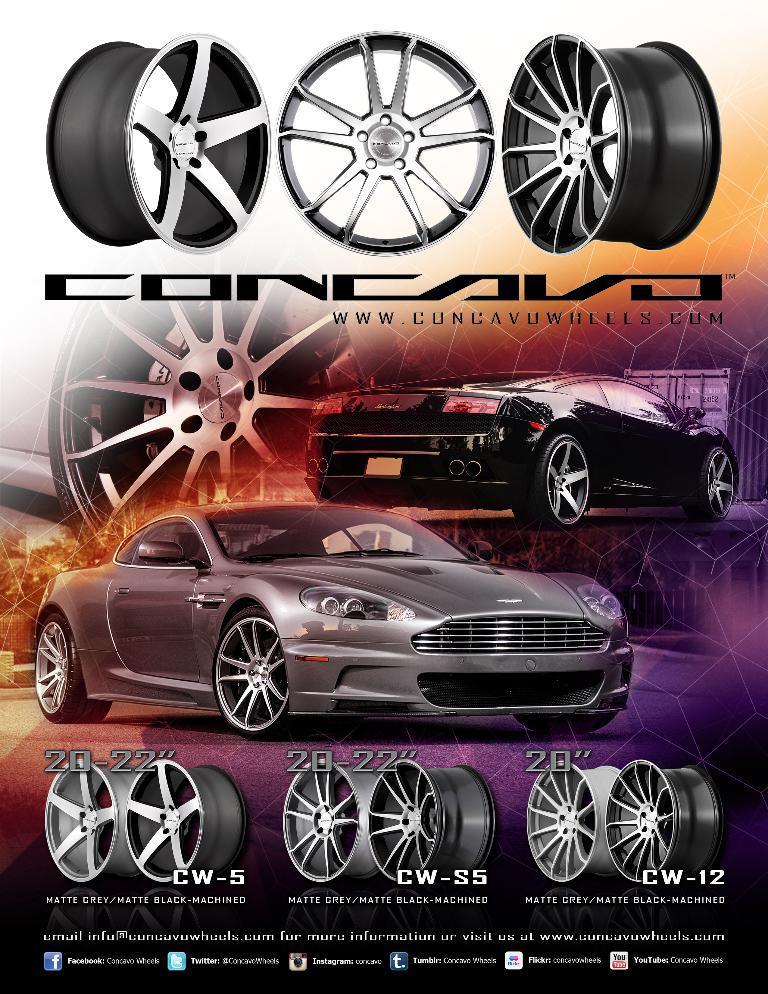Please provide a concise description of this image. In this picture there is a poster. In that poster we can see the cars wheels. In the center we can see grey and black car. At the bottom we can see the quotation. 